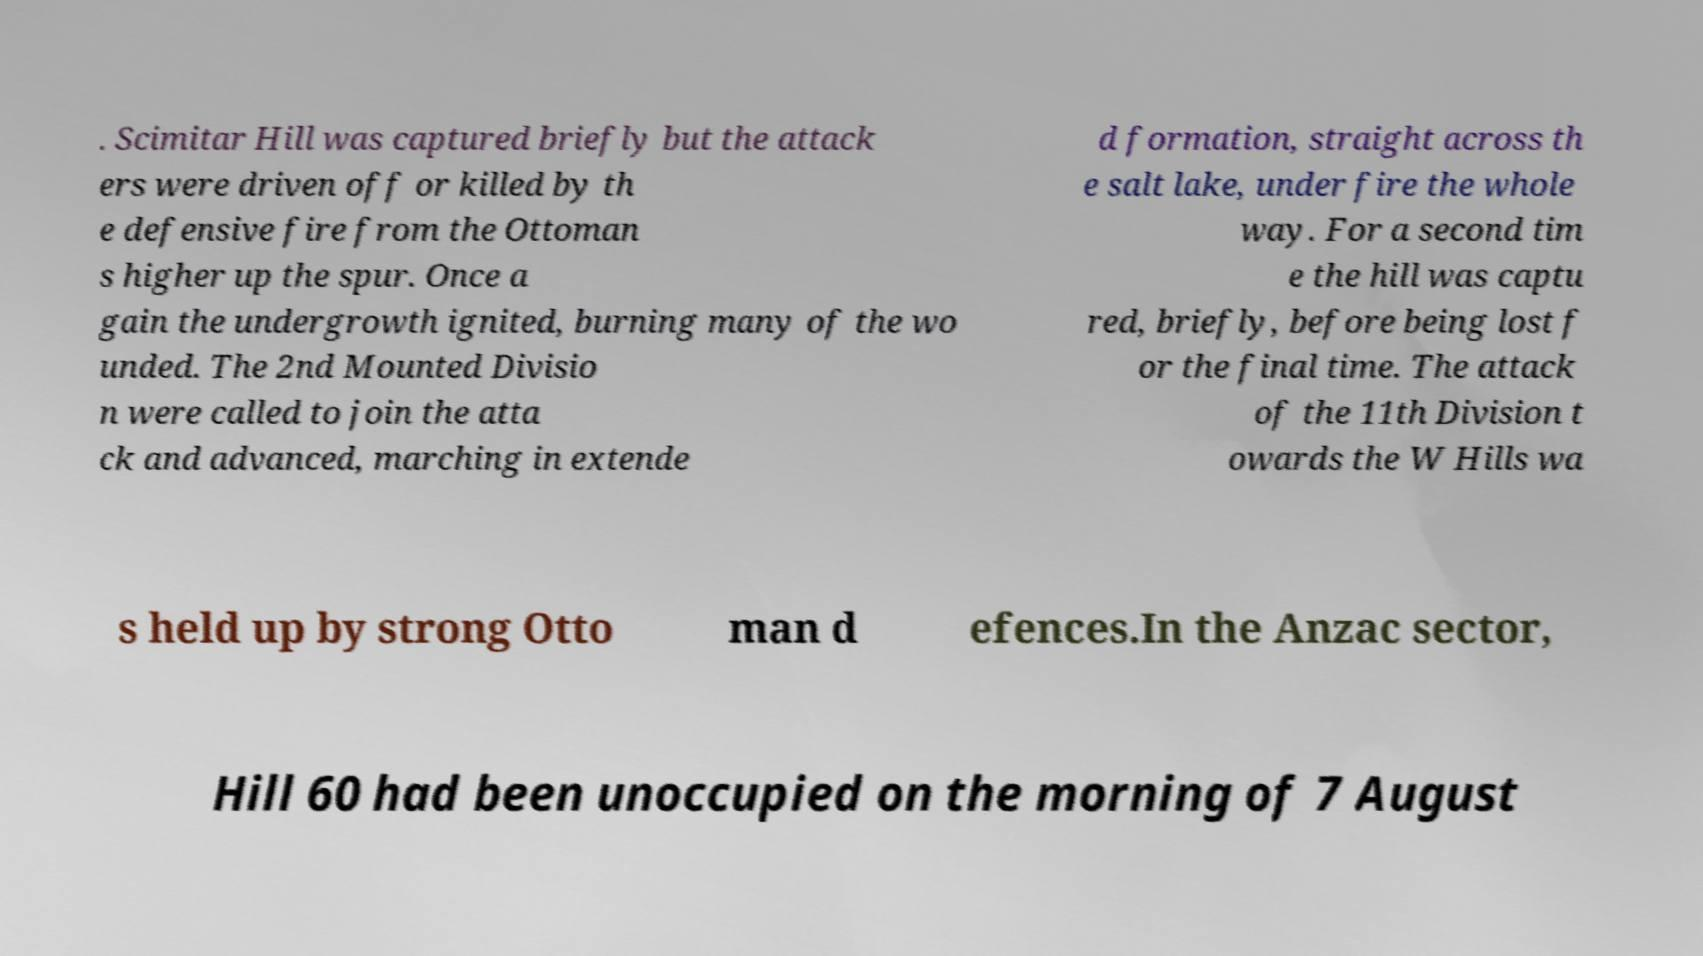Can you read and provide the text displayed in the image?This photo seems to have some interesting text. Can you extract and type it out for me? . Scimitar Hill was captured briefly but the attack ers were driven off or killed by th e defensive fire from the Ottoman s higher up the spur. Once a gain the undergrowth ignited, burning many of the wo unded. The 2nd Mounted Divisio n were called to join the atta ck and advanced, marching in extende d formation, straight across th e salt lake, under fire the whole way. For a second tim e the hill was captu red, briefly, before being lost f or the final time. The attack of the 11th Division t owards the W Hills wa s held up by strong Otto man d efences.In the Anzac sector, Hill 60 had been unoccupied on the morning of 7 August 